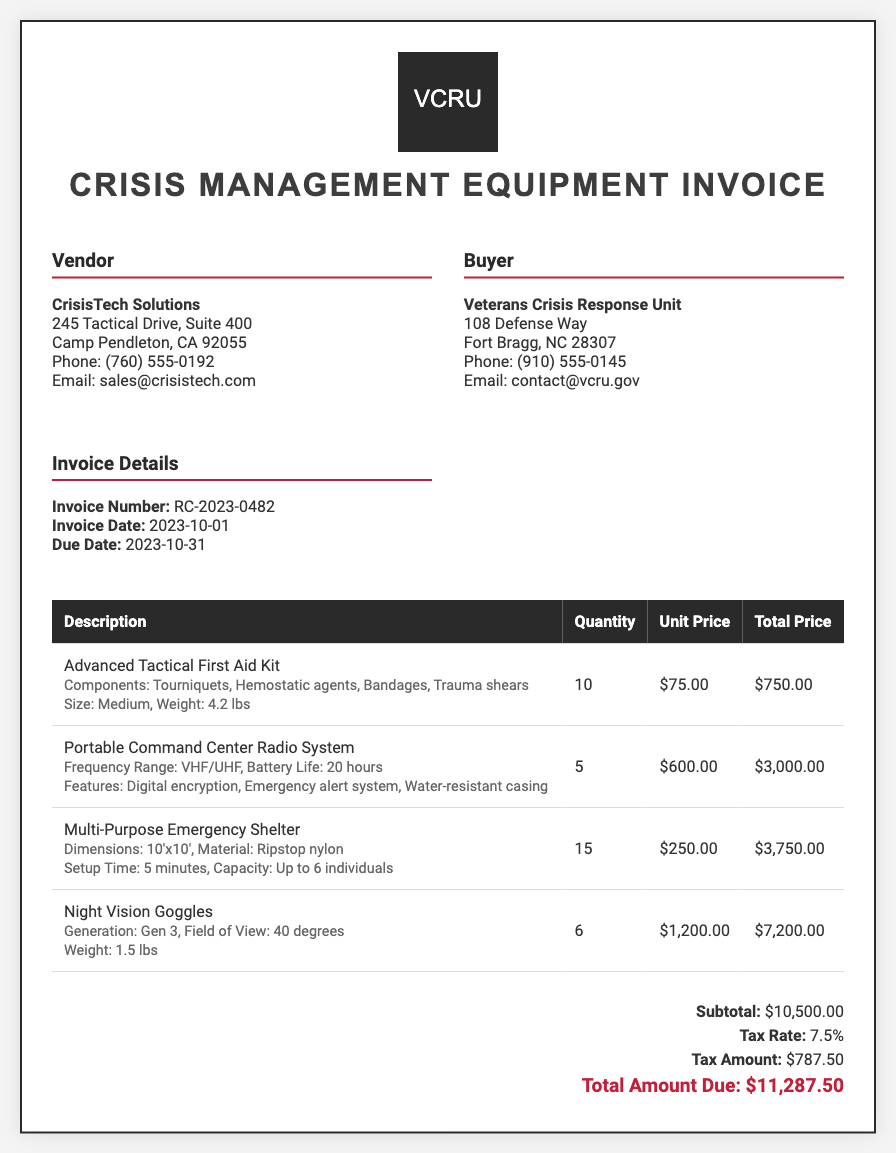What is the vendor's name? The vendor's name is indicated in the document under the "Vendor" section.
Answer: CrisisTech Solutions What is the invoice number? The invoice number is specified in the "Invoice Details" section of the document.
Answer: RC-2023-0482 What is the quantity of Night Vision Goggles ordered? The quantity of Night Vision Goggles can be found in the table under the relevant product description.
Answer: 6 What is the total amount due? The total amount due is listed in the summary section of the invoice, which includes the calculations of subtotal and tax.
Answer: $11,287.50 What is the tax rate applied to the invoice? The tax rate is specified in the summary section of the document.
Answer: 7.5% What type of item is the "Multi-Purpose Emergency Shelter"? This information can be identified in the description section of that particular item in the table.
Answer: Shelter How many Advanced Tactical First Aid Kits were purchased? The number of Advanced Tactical First Aid Kits is provided in the quantity column of the appropriate row in the table.
Answer: 10 What is the total price for the Portable Command Center Radio System? The total price can be found in the total price column of the corresponding row in the invoice.
Answer: $3,000.00 What is the due date for the invoice? The due date is listed in the "Invoice Details" section alongside the invoice number and invoice date.
Answer: 2023-10-31 